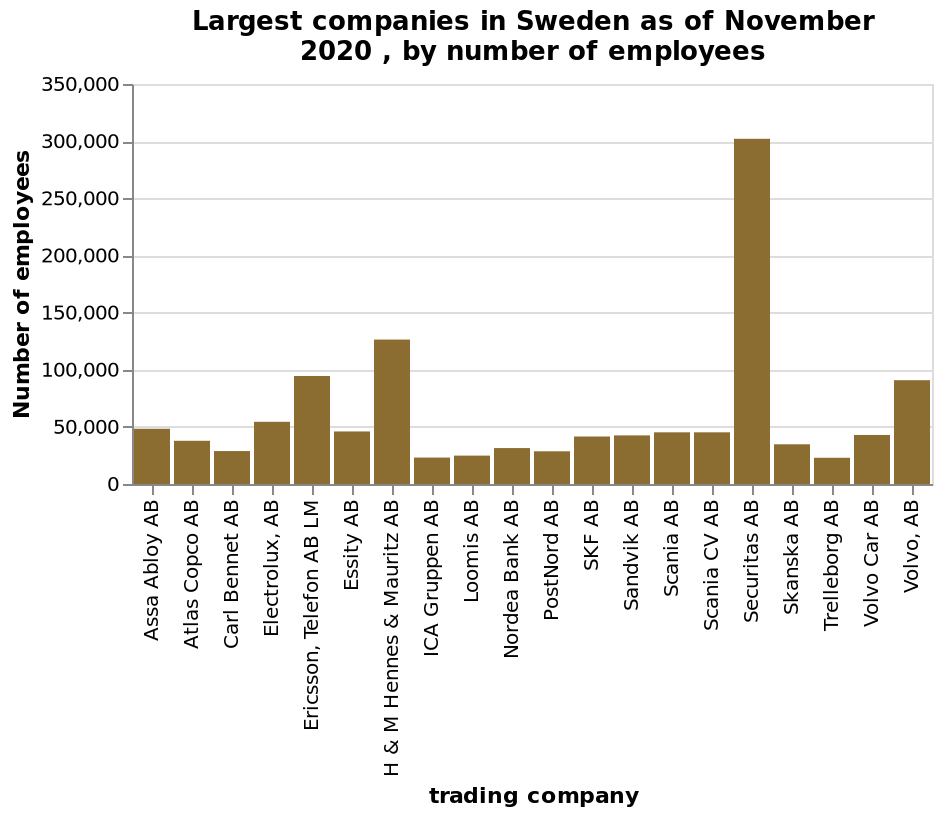<image>
please summary the statistics and relations of the chart The chart shows that the company called Securitas AB has, by far, the largest number of employees at over 300 thousand. The next-largest company is H&M Hennes & Mauritz AB with less than half the employees of Securitas - about 125 thousand. 15 of the 20 companies in the chart had fewer than 50 thousand employees. What is the title of the bar graph?  The title of the bar graph is "Largest companies in Sweden as of November 2020, by number of employees." What is the approximate number of employees in Securitas AB? Securitas AB has over 300 thousand employees. How many companies out of the 20 in the chart have fewer than 50 thousand employees? Fifteen out of the 20 companies in the chart have fewer than 50 thousand employees. 